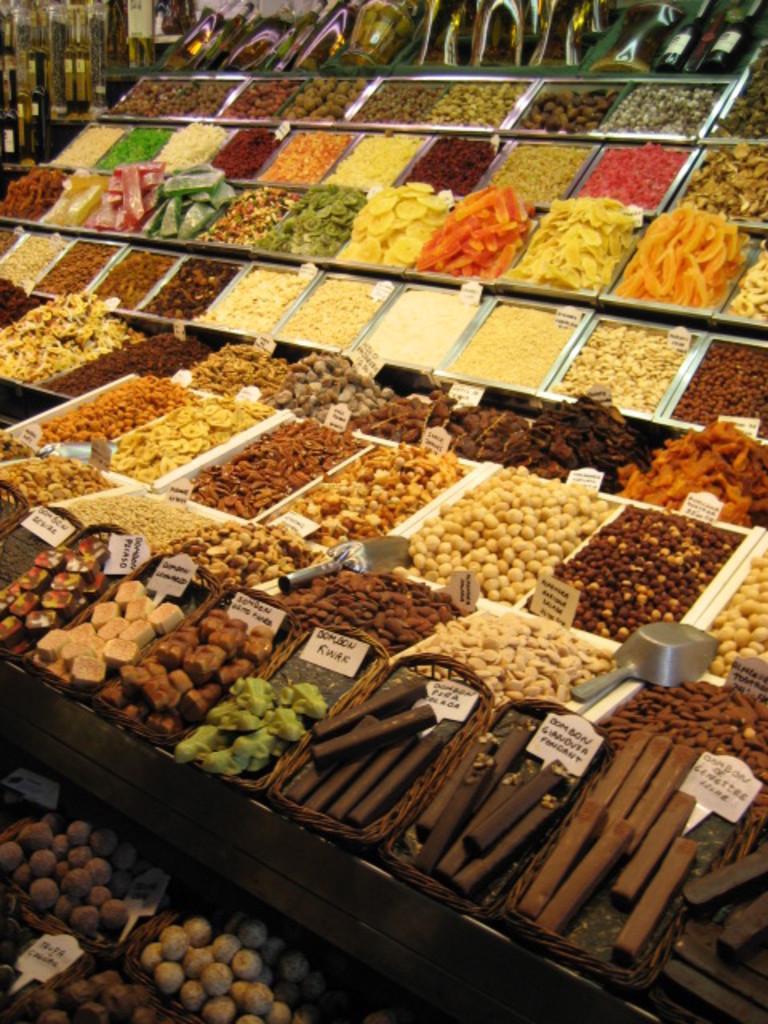Describe this image in one or two sentences. In the image there are many snacks, nuts and other cooking items divided into to some parts and kept in the display. 